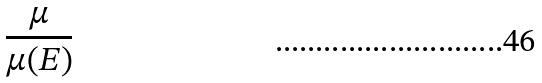<formula> <loc_0><loc_0><loc_500><loc_500>\frac { \mu } { \mu ( E ) }</formula> 